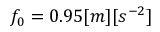Convert formula to latex. <formula><loc_0><loc_0><loc_500><loc_500>f _ { 0 } = 0 . 9 5 [ m ] [ s ^ { - 2 } ]</formula> 